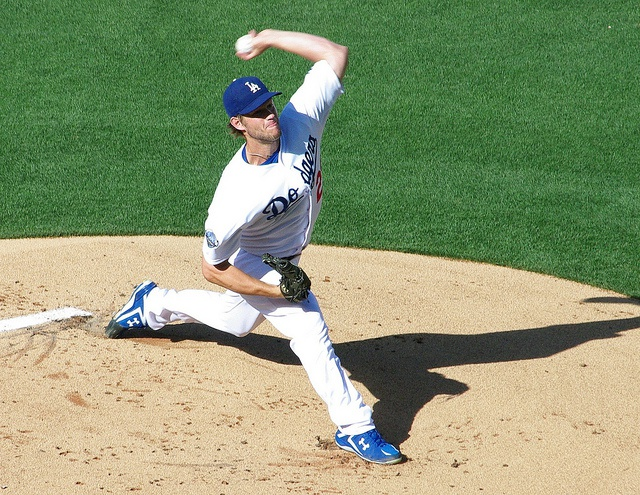Describe the objects in this image and their specific colors. I can see people in green, white, gray, and black tones, baseball glove in green, black, gray, and tan tones, and sports ball in green, white, darkgray, and beige tones in this image. 